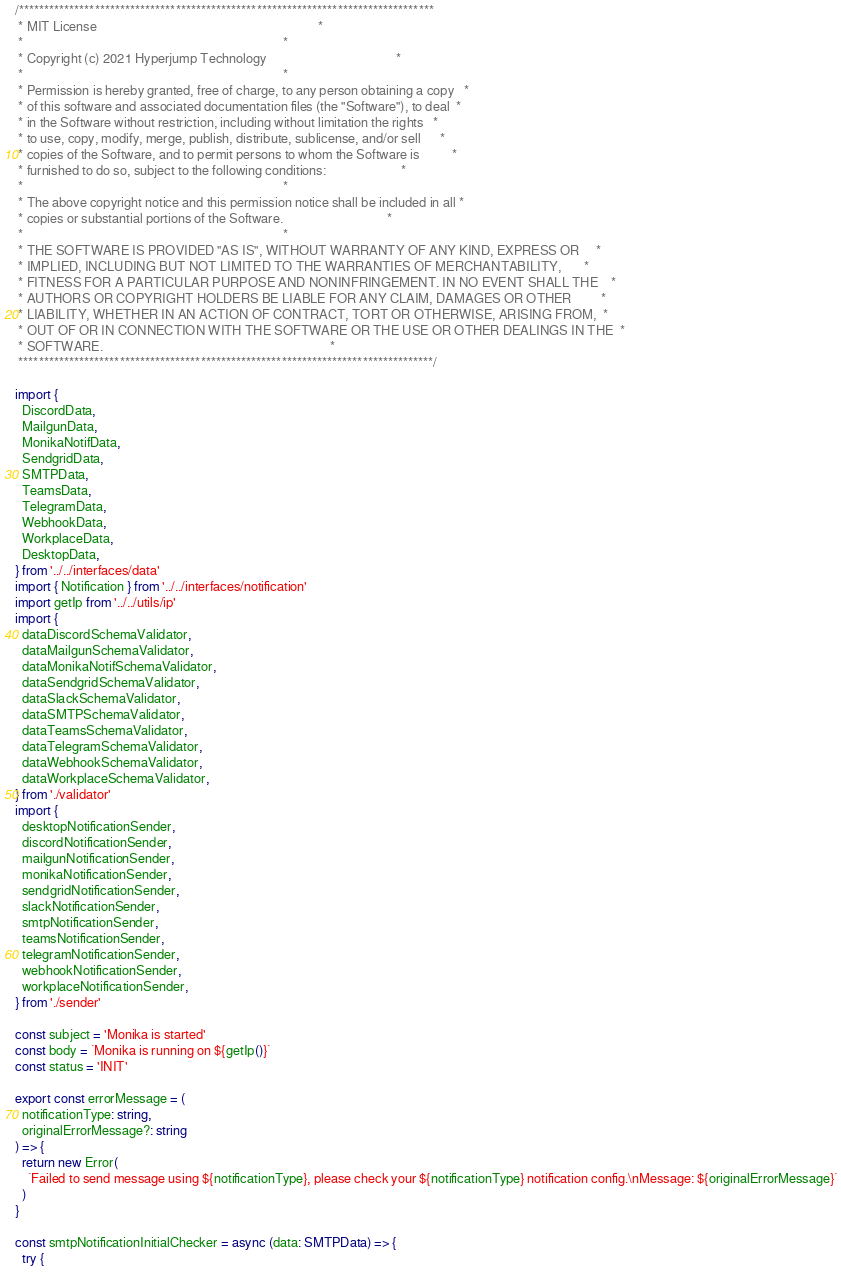<code> <loc_0><loc_0><loc_500><loc_500><_TypeScript_>/**********************************************************************************
 * MIT License                                                                    *
 *                                                                                *
 * Copyright (c) 2021 Hyperjump Technology                                        *
 *                                                                                *
 * Permission is hereby granted, free of charge, to any person obtaining a copy   *
 * of this software and associated documentation files (the "Software"), to deal  *
 * in the Software without restriction, including without limitation the rights   *
 * to use, copy, modify, merge, publish, distribute, sublicense, and/or sell      *
 * copies of the Software, and to permit persons to whom the Software is          *
 * furnished to do so, subject to the following conditions:                       *
 *                                                                                *
 * The above copyright notice and this permission notice shall be included in all *
 * copies or substantial portions of the Software.                                *
 *                                                                                *
 * THE SOFTWARE IS PROVIDED "AS IS", WITHOUT WARRANTY OF ANY KIND, EXPRESS OR     *
 * IMPLIED, INCLUDING BUT NOT LIMITED TO THE WARRANTIES OF MERCHANTABILITY,       *
 * FITNESS FOR A PARTICULAR PURPOSE AND NONINFRINGEMENT. IN NO EVENT SHALL THE    *
 * AUTHORS OR COPYRIGHT HOLDERS BE LIABLE FOR ANY CLAIM, DAMAGES OR OTHER         *
 * LIABILITY, WHETHER IN AN ACTION OF CONTRACT, TORT OR OTHERWISE, ARISING FROM,  *
 * OUT OF OR IN CONNECTION WITH THE SOFTWARE OR THE USE OR OTHER DEALINGS IN THE  *
 * SOFTWARE.                                                                      *
 **********************************************************************************/

import {
  DiscordData,
  MailgunData,
  MonikaNotifData,
  SendgridData,
  SMTPData,
  TeamsData,
  TelegramData,
  WebhookData,
  WorkplaceData,
  DesktopData,
} from '../../interfaces/data'
import { Notification } from '../../interfaces/notification'
import getIp from '../../utils/ip'
import {
  dataDiscordSchemaValidator,
  dataMailgunSchemaValidator,
  dataMonikaNotifSchemaValidator,
  dataSendgridSchemaValidator,
  dataSlackSchemaValidator,
  dataSMTPSchemaValidator,
  dataTeamsSchemaValidator,
  dataTelegramSchemaValidator,
  dataWebhookSchemaValidator,
  dataWorkplaceSchemaValidator,
} from './validator'
import {
  desktopNotificationSender,
  discordNotificationSender,
  mailgunNotificationSender,
  monikaNotificationSender,
  sendgridNotificationSender,
  slackNotificationSender,
  smtpNotificationSender,
  teamsNotificationSender,
  telegramNotificationSender,
  webhookNotificationSender,
  workplaceNotificationSender,
} from './sender'

const subject = 'Monika is started'
const body = `Monika is running on ${getIp()}`
const status = 'INIT'

export const errorMessage = (
  notificationType: string,
  originalErrorMessage?: string
) => {
  return new Error(
    `Failed to send message using ${notificationType}, please check your ${notificationType} notification config.\nMessage: ${originalErrorMessage}`
  )
}

const smtpNotificationInitialChecker = async (data: SMTPData) => {
  try {</code> 